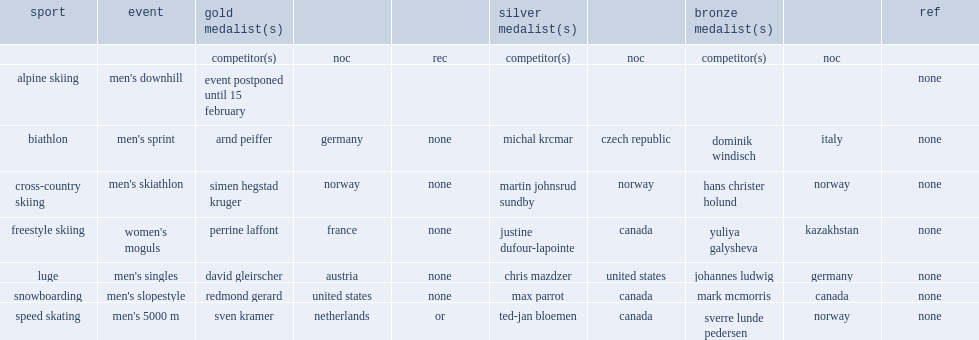Who was the gold medalist in freestyle skiing women's moguls at france? Perrine laffont. 